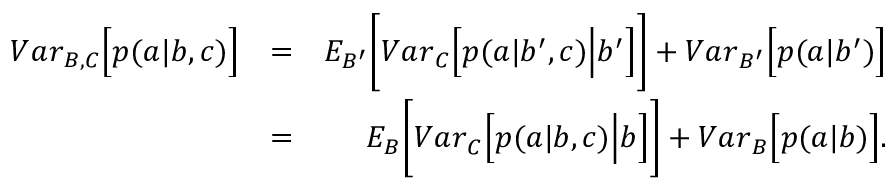<formula> <loc_0><loc_0><loc_500><loc_500>\begin{array} { r l r } { { V a r } _ { B , C } \left [ p ( a | b , c ) \right ] } & { = } & { { E } _ { B ^ { \prime } } \left [ { V a r } _ { C } \left [ p ( a | b ^ { \prime } , c ) \left | b ^ { \prime } \right ] \right ] + { V a r } _ { B ^ { \prime } } \left [ p ( a | b ^ { \prime } ) \right ] } \\ & { = } & { { E } _ { B } \left [ { V a r } _ { C } \left [ p ( a | b , c ) \right | b \right ] \right ] + { V a r } _ { B } \left [ p ( a | b ) \right ] . } \end{array}</formula> 